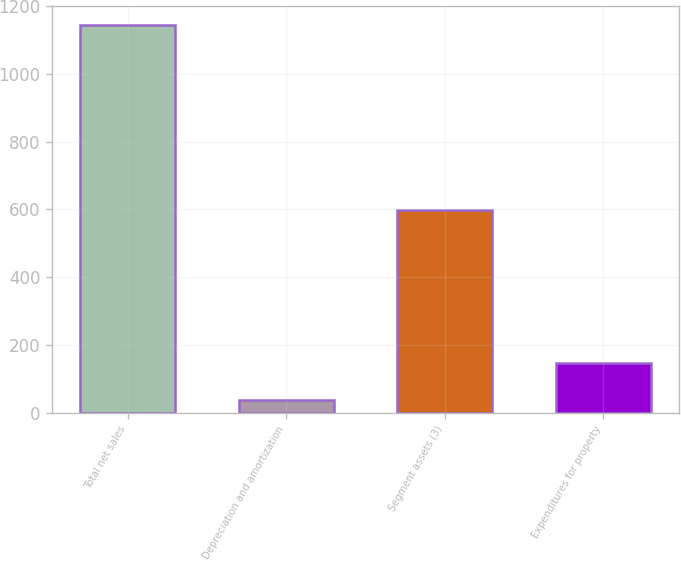Convert chart to OTSL. <chart><loc_0><loc_0><loc_500><loc_500><bar_chart><fcel>Total net sales<fcel>Depreciation and amortization<fcel>Segment assets (3)<fcel>Expenditures for property<nl><fcel>1144<fcel>36<fcel>597<fcel>146.8<nl></chart> 